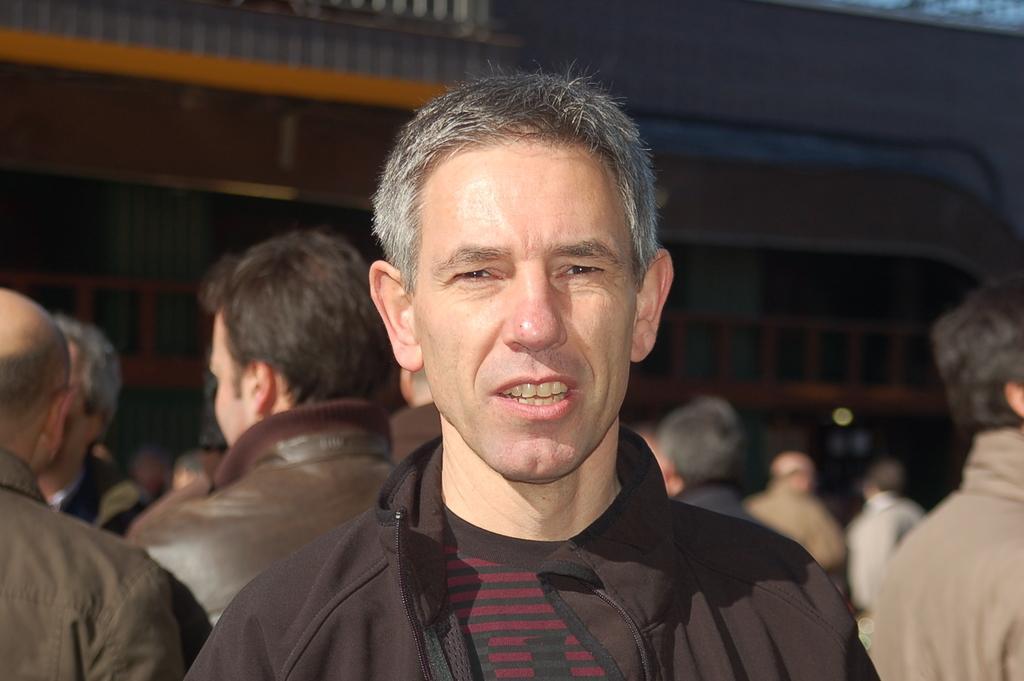Describe this image in one or two sentences. In this image in the front man there is a man having some expression on his face. In the background there are persons and there is a building. 